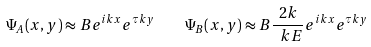Convert formula to latex. <formula><loc_0><loc_0><loc_500><loc_500>\Psi _ { A } ( x , y ) \approx B e ^ { i k x } e ^ { \tau k y } \quad \Psi _ { B } ( x , y ) \approx B \frac { 2 k } { \ k E } e ^ { i k x } e ^ { \tau k y }</formula> 